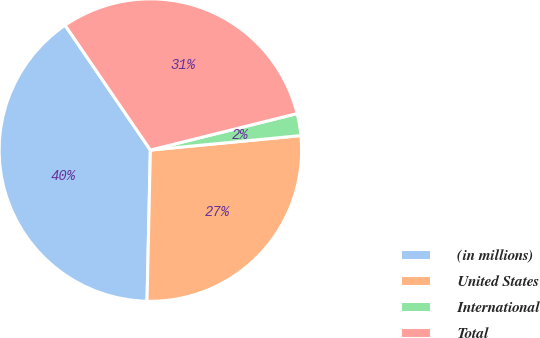<chart> <loc_0><loc_0><loc_500><loc_500><pie_chart><fcel>(in millions)<fcel>United States<fcel>International<fcel>Total<nl><fcel>40.11%<fcel>26.88%<fcel>2.35%<fcel>30.66%<nl></chart> 